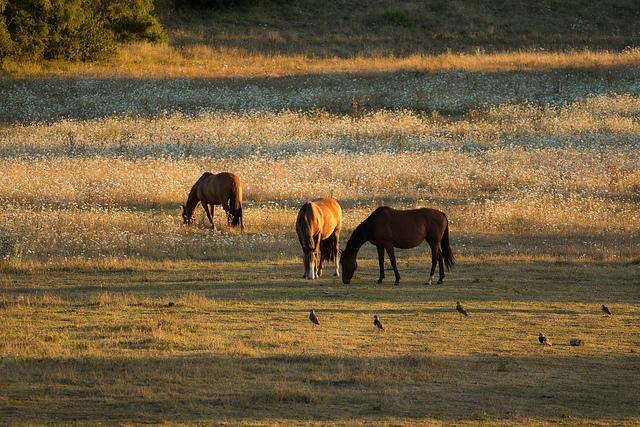How many horses are there?
Give a very brief answer. 3. How many birds are there?
Give a very brief answer. 5. How many girls are there?
Give a very brief answer. 0. 